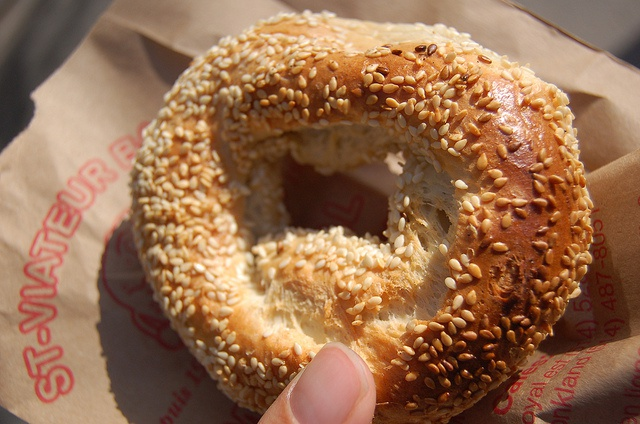Describe the objects in this image and their specific colors. I can see donut in gray, maroon, brown, and tan tones and people in gray and salmon tones in this image. 